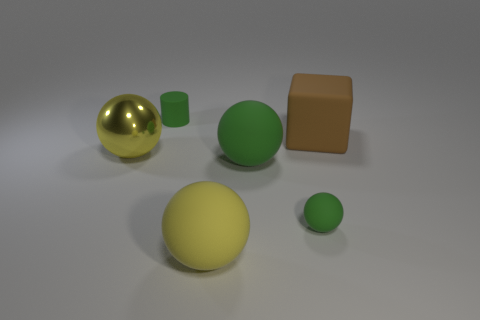Subtract all green cylinders. How many yellow balls are left? 2 Subtract all shiny spheres. How many spheres are left? 3 Add 4 rubber things. How many objects exist? 10 Subtract 1 balls. How many balls are left? 3 Subtract all cubes. How many objects are left? 5 Subtract all brown balls. Subtract all cyan cubes. How many balls are left? 4 Subtract all red metallic cylinders. Subtract all green things. How many objects are left? 3 Add 4 large yellow rubber spheres. How many large yellow rubber spheres are left? 5 Add 3 large green things. How many large green things exist? 4 Subtract 0 yellow cubes. How many objects are left? 6 